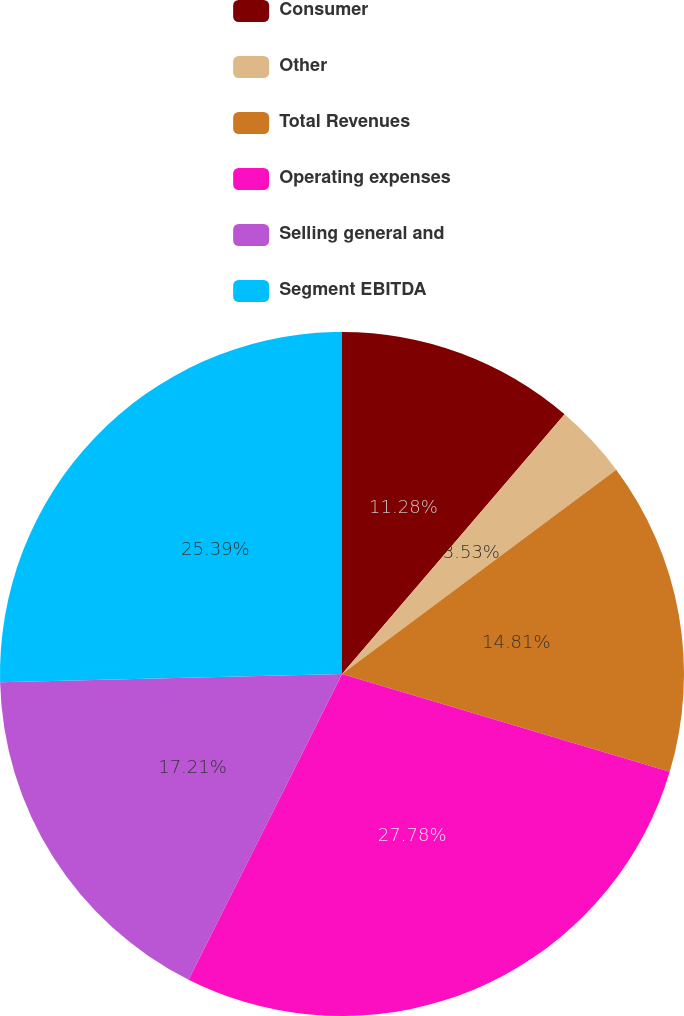Convert chart to OTSL. <chart><loc_0><loc_0><loc_500><loc_500><pie_chart><fcel>Consumer<fcel>Other<fcel>Total Revenues<fcel>Operating expenses<fcel>Selling general and<fcel>Segment EBITDA<nl><fcel>11.28%<fcel>3.53%<fcel>14.81%<fcel>27.79%<fcel>17.21%<fcel>25.39%<nl></chart> 